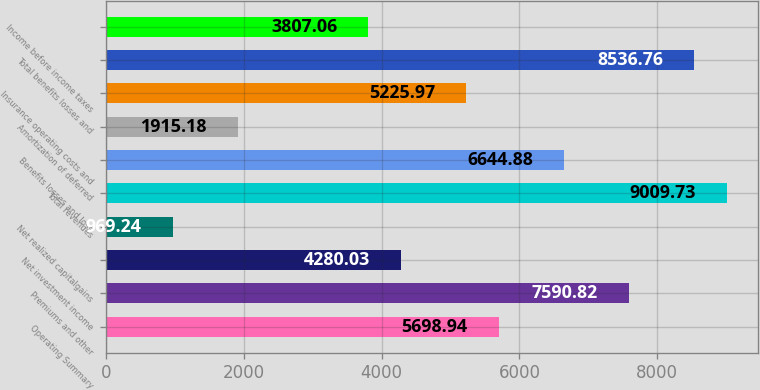Convert chart to OTSL. <chart><loc_0><loc_0><loc_500><loc_500><bar_chart><fcel>Operating Summary<fcel>Premiums and other<fcel>Net investment income<fcel>Net realized capitalgains<fcel>Total revenues<fcel>Benefits losses and loss<fcel>Amortization of deferred<fcel>Insurance operating costs and<fcel>Total benefits losses and<fcel>Income before income taxes<nl><fcel>5698.94<fcel>7590.82<fcel>4280.03<fcel>969.24<fcel>9009.73<fcel>6644.88<fcel>1915.18<fcel>5225.97<fcel>8536.76<fcel>3807.06<nl></chart> 